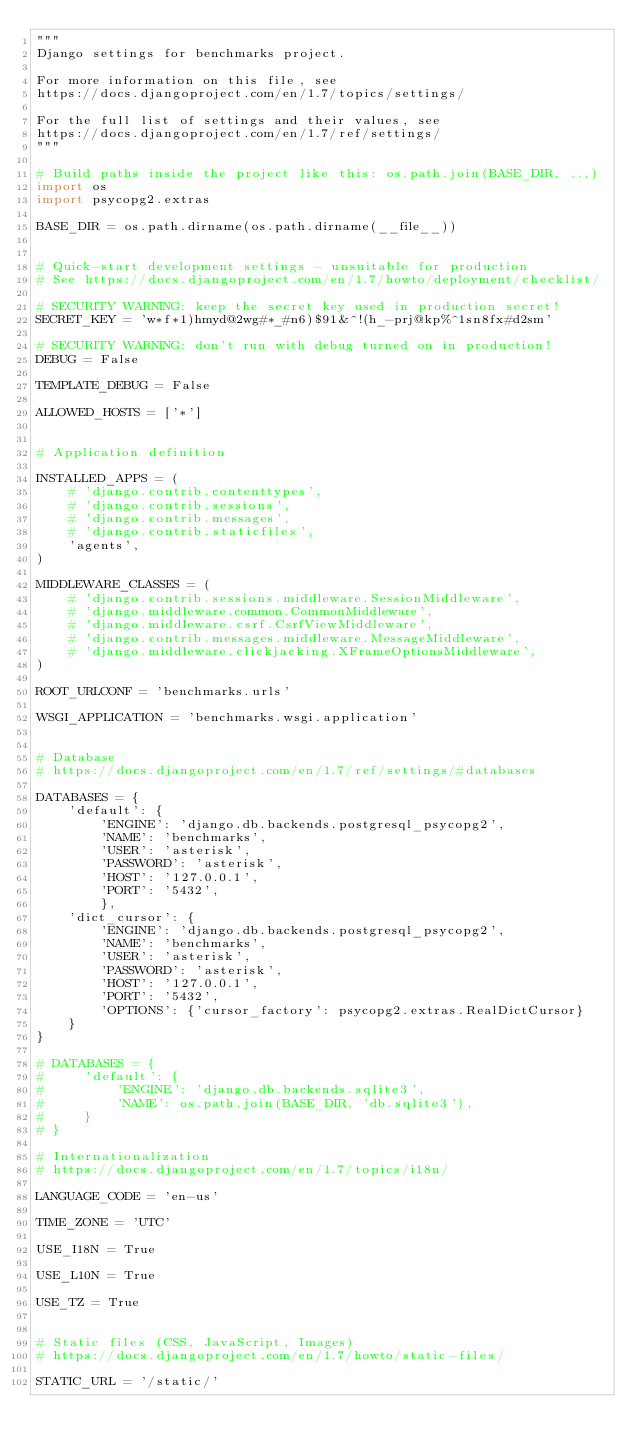<code> <loc_0><loc_0><loc_500><loc_500><_Python_>"""
Django settings for benchmarks project.

For more information on this file, see
https://docs.djangoproject.com/en/1.7/topics/settings/

For the full list of settings and their values, see
https://docs.djangoproject.com/en/1.7/ref/settings/
"""

# Build paths inside the project like this: os.path.join(BASE_DIR, ...)
import os
import psycopg2.extras

BASE_DIR = os.path.dirname(os.path.dirname(__file__))


# Quick-start development settings - unsuitable for production
# See https://docs.djangoproject.com/en/1.7/howto/deployment/checklist/

# SECURITY WARNING: keep the secret key used in production secret!
SECRET_KEY = 'w*f*1)hmyd@2wg#*_#n6)$91&^!(h_-prj@kp%^1sn8fx#d2sm'

# SECURITY WARNING: don't run with debug turned on in production!
DEBUG = False

TEMPLATE_DEBUG = False

ALLOWED_HOSTS = ['*']


# Application definition

INSTALLED_APPS = (
    # 'django.contrib.contenttypes',
    # 'django.contrib.sessions',
    # 'django.contrib.messages',
    # 'django.contrib.staticfiles',
    'agents',
)

MIDDLEWARE_CLASSES = (
    # 'django.contrib.sessions.middleware.SessionMiddleware',
    # 'django.middleware.common.CommonMiddleware',
    # 'django.middleware.csrf.CsrfViewMiddleware',
    # 'django.contrib.messages.middleware.MessageMiddleware',
    # 'django.middleware.clickjacking.XFrameOptionsMiddleware',
)

ROOT_URLCONF = 'benchmarks.urls'

WSGI_APPLICATION = 'benchmarks.wsgi.application'


# Database
# https://docs.djangoproject.com/en/1.7/ref/settings/#databases

DATABASES = {
    'default': {
        'ENGINE': 'django.db.backends.postgresql_psycopg2',
        'NAME': 'benchmarks',
        'USER': 'asterisk',
        'PASSWORD': 'asterisk',
        'HOST': '127.0.0.1',
        'PORT': '5432',
        },
    'dict_cursor': {
        'ENGINE': 'django.db.backends.postgresql_psycopg2',
        'NAME': 'benchmarks',
        'USER': 'asterisk',
        'PASSWORD': 'asterisk',
        'HOST': '127.0.0.1',
        'PORT': '5432',
        'OPTIONS': {'cursor_factory': psycopg2.extras.RealDictCursor}
    }
}

# DATABASES = {
#     'default': {
#         'ENGINE': 'django.db.backends.sqlite3',
#         'NAME': os.path.join(BASE_DIR, 'db.sqlite3'),
#     }
# }

# Internationalization
# https://docs.djangoproject.com/en/1.7/topics/i18n/

LANGUAGE_CODE = 'en-us'

TIME_ZONE = 'UTC'

USE_I18N = True

USE_L10N = True

USE_TZ = True


# Static files (CSS, JavaScript, Images)
# https://docs.djangoproject.com/en/1.7/howto/static-files/

STATIC_URL = '/static/'</code> 